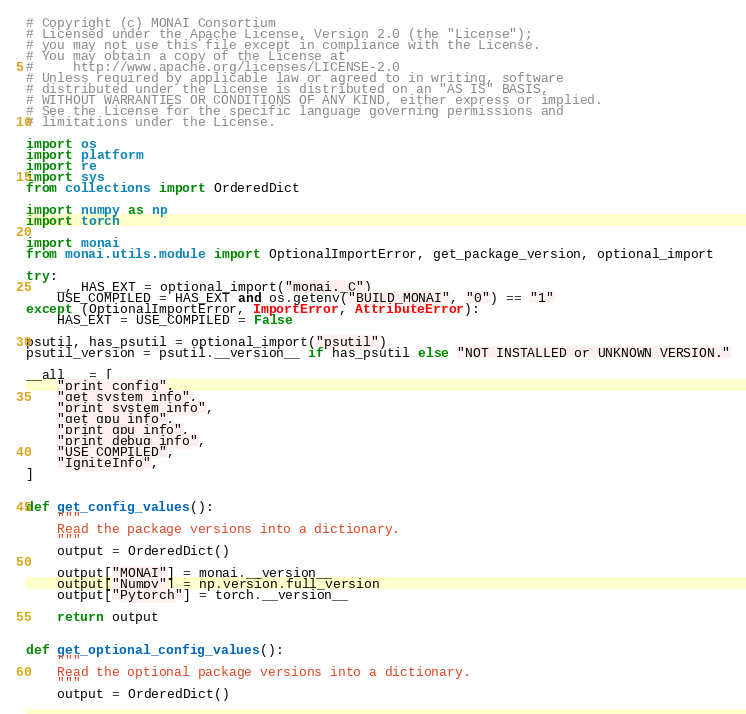<code> <loc_0><loc_0><loc_500><loc_500><_Python_># Copyright (c) MONAI Consortium
# Licensed under the Apache License, Version 2.0 (the "License");
# you may not use this file except in compliance with the License.
# You may obtain a copy of the License at
#     http://www.apache.org/licenses/LICENSE-2.0
# Unless required by applicable law or agreed to in writing, software
# distributed under the License is distributed on an "AS IS" BASIS,
# WITHOUT WARRANTIES OR CONDITIONS OF ANY KIND, either express or implied.
# See the License for the specific language governing permissions and
# limitations under the License.

import os
import platform
import re
import sys
from collections import OrderedDict

import numpy as np
import torch

import monai
from monai.utils.module import OptionalImportError, get_package_version, optional_import

try:
    _, HAS_EXT = optional_import("monai._C")
    USE_COMPILED = HAS_EXT and os.getenv("BUILD_MONAI", "0") == "1"
except (OptionalImportError, ImportError, AttributeError):
    HAS_EXT = USE_COMPILED = False

psutil, has_psutil = optional_import("psutil")
psutil_version = psutil.__version__ if has_psutil else "NOT INSTALLED or UNKNOWN VERSION."

__all__ = [
    "print_config",
    "get_system_info",
    "print_system_info",
    "get_gpu_info",
    "print_gpu_info",
    "print_debug_info",
    "USE_COMPILED",
    "IgniteInfo",
]


def get_config_values():
    """
    Read the package versions into a dictionary.
    """
    output = OrderedDict()

    output["MONAI"] = monai.__version__
    output["Numpy"] = np.version.full_version
    output["Pytorch"] = torch.__version__

    return output


def get_optional_config_values():
    """
    Read the optional package versions into a dictionary.
    """
    output = OrderedDict()
</code> 